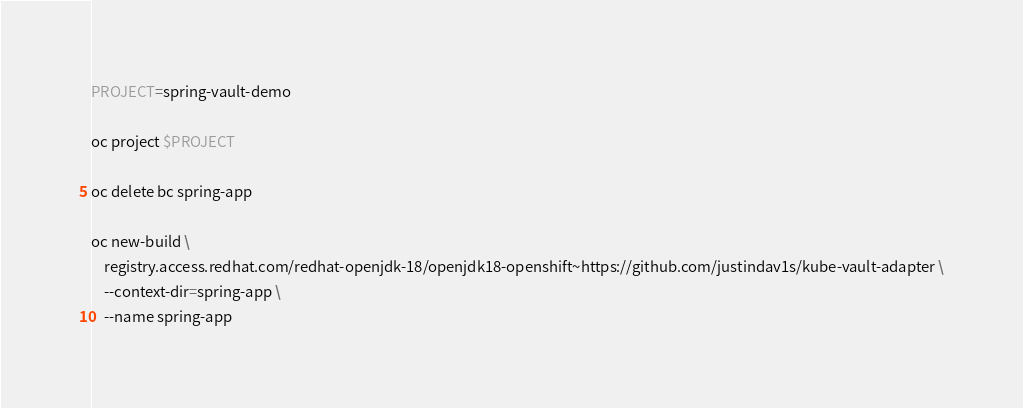<code> <loc_0><loc_0><loc_500><loc_500><_Bash_>PROJECT=spring-vault-demo

oc project $PROJECT

oc delete bc spring-app

oc new-build \
    registry.access.redhat.com/redhat-openjdk-18/openjdk18-openshift~https://github.com/justindav1s/kube-vault-adapter \
    --context-dir=spring-app \
    --name spring-app

</code> 